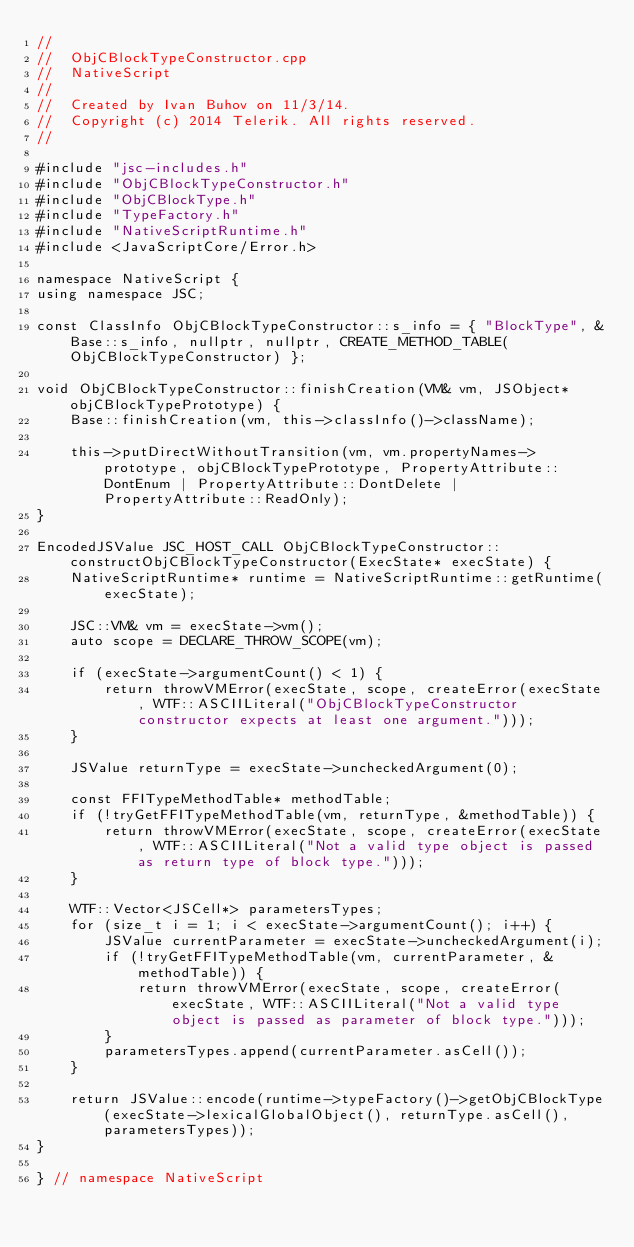<code> <loc_0><loc_0><loc_500><loc_500><_ObjectiveC_>//
//  ObjCBlockTypeConstructor.cpp
//  NativeScript
//
//  Created by Ivan Buhov on 11/3/14.
//  Copyright (c) 2014 Telerik. All rights reserved.
//

#include "jsc-includes.h"
#include "ObjCBlockTypeConstructor.h"
#include "ObjCBlockType.h"
#include "TypeFactory.h"
#include "NativeScriptRuntime.h"
#include <JavaScriptCore/Error.h>

namespace NativeScript {
using namespace JSC;

const ClassInfo ObjCBlockTypeConstructor::s_info = { "BlockType", &Base::s_info, nullptr, nullptr, CREATE_METHOD_TABLE(ObjCBlockTypeConstructor) };

void ObjCBlockTypeConstructor::finishCreation(VM& vm, JSObject* objCBlockTypePrototype) {
    Base::finishCreation(vm, this->classInfo()->className);

    this->putDirectWithoutTransition(vm, vm.propertyNames->prototype, objCBlockTypePrototype, PropertyAttribute::DontEnum | PropertyAttribute::DontDelete | PropertyAttribute::ReadOnly);
}

EncodedJSValue JSC_HOST_CALL ObjCBlockTypeConstructor::constructObjCBlockTypeConstructor(ExecState* execState) {
    NativeScriptRuntime* runtime = NativeScriptRuntime::getRuntime(execState);

    JSC::VM& vm = execState->vm();
    auto scope = DECLARE_THROW_SCOPE(vm);

    if (execState->argumentCount() < 1) {
        return throwVMError(execState, scope, createError(execState, WTF::ASCIILiteral("ObjCBlockTypeConstructor constructor expects at least one argument.")));
    }

    JSValue returnType = execState->uncheckedArgument(0);

    const FFITypeMethodTable* methodTable;
    if (!tryGetFFITypeMethodTable(vm, returnType, &methodTable)) {
        return throwVMError(execState, scope, createError(execState, WTF::ASCIILiteral("Not a valid type object is passed as return type of block type.")));
    }

    WTF::Vector<JSCell*> parametersTypes;
    for (size_t i = 1; i < execState->argumentCount(); i++) {
        JSValue currentParameter = execState->uncheckedArgument(i);
        if (!tryGetFFITypeMethodTable(vm, currentParameter, &methodTable)) {
            return throwVMError(execState, scope, createError(execState, WTF::ASCIILiteral("Not a valid type object is passed as parameter of block type.")));
        }
        parametersTypes.append(currentParameter.asCell());
    }

    return JSValue::encode(runtime->typeFactory()->getObjCBlockType(execState->lexicalGlobalObject(), returnType.asCell(), parametersTypes));
}

} // namespace NativeScript
</code> 